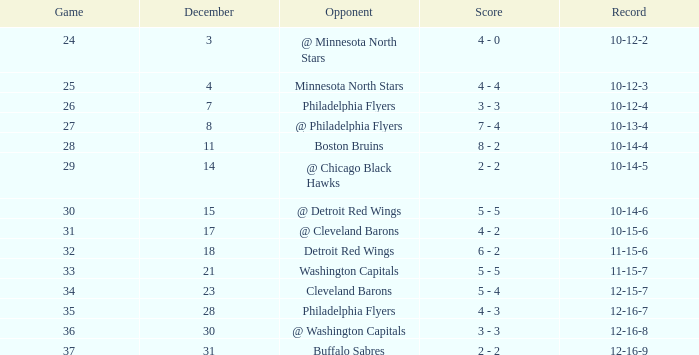What is Opponent, when Game is "37"? Buffalo Sabres. 